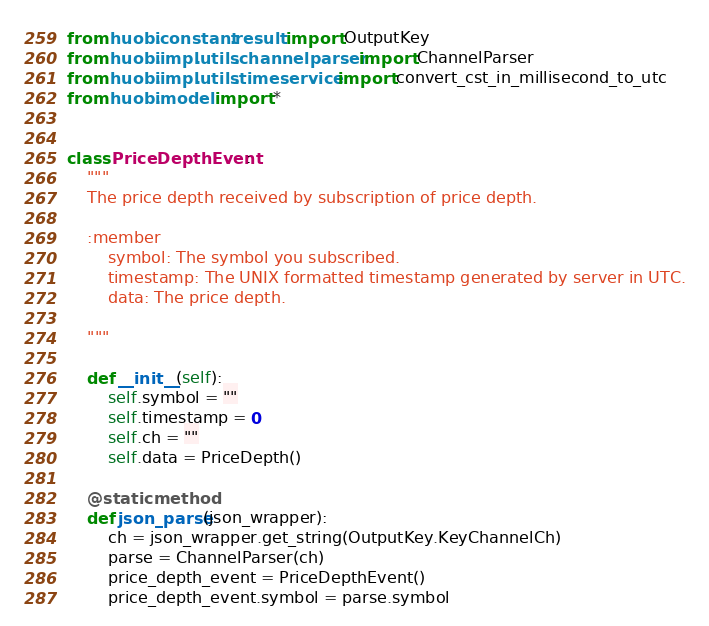<code> <loc_0><loc_0><loc_500><loc_500><_Python_>from huobi.constant.result import OutputKey
from huobi.impl.utils.channelparser import ChannelParser
from huobi.impl.utils.timeservice import convert_cst_in_millisecond_to_utc
from huobi.model import *


class PriceDepthEvent:
    """
    The price depth received by subscription of price depth.

    :member
        symbol: The symbol you subscribed.
        timestamp: The UNIX formatted timestamp generated by server in UTC.
        data: The price depth.

    """

    def __init__(self):
        self.symbol = ""
        self.timestamp = 0
        self.ch = ""
        self.data = PriceDepth()

    @staticmethod
    def json_parse(json_wrapper):
        ch = json_wrapper.get_string(OutputKey.KeyChannelCh)
        parse = ChannelParser(ch)
        price_depth_event = PriceDepthEvent()
        price_depth_event.symbol = parse.symbol</code> 